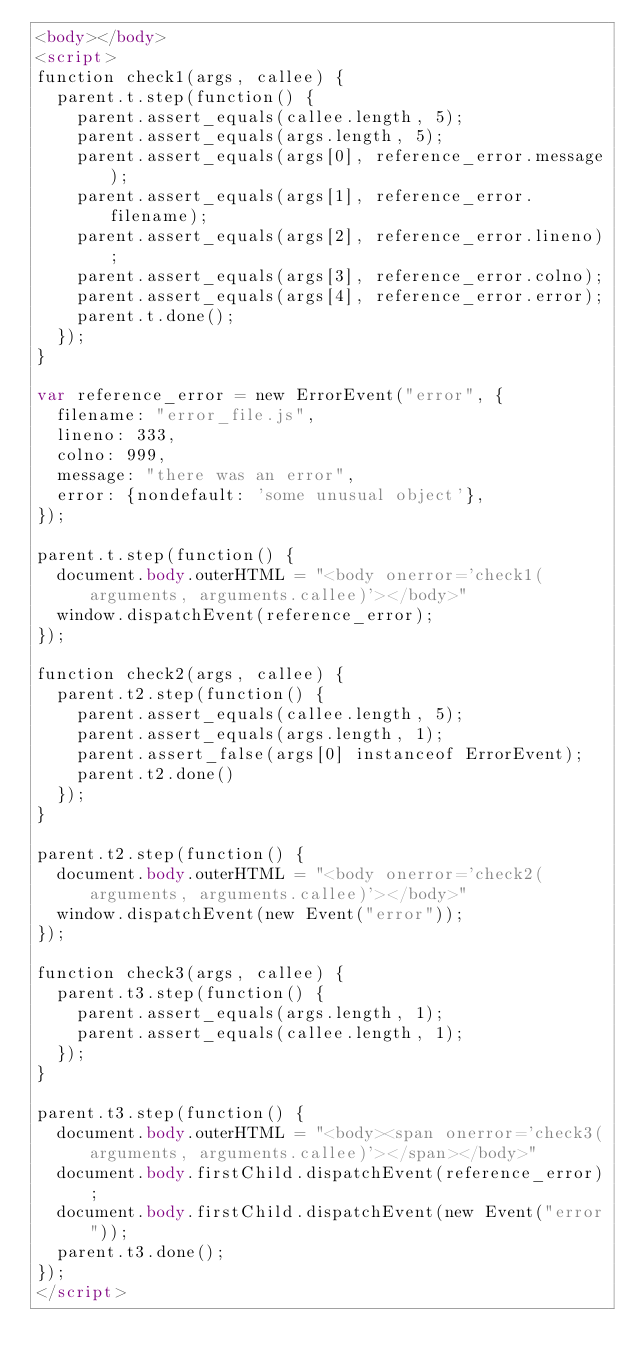<code> <loc_0><loc_0><loc_500><loc_500><_HTML_><body></body>
<script>
function check1(args, callee) {
  parent.t.step(function() {
    parent.assert_equals(callee.length, 5);
    parent.assert_equals(args.length, 5);
    parent.assert_equals(args[0], reference_error.message);
    parent.assert_equals(args[1], reference_error.filename);
    parent.assert_equals(args[2], reference_error.lineno);
    parent.assert_equals(args[3], reference_error.colno);
    parent.assert_equals(args[4], reference_error.error);
    parent.t.done();
  });
}

var reference_error = new ErrorEvent("error", {
  filename: "error_file.js",
  lineno: 333,
  colno: 999,
  message: "there was an error",
  error: {nondefault: 'some unusual object'},
});

parent.t.step(function() {
  document.body.outerHTML = "<body onerror='check1(arguments, arguments.callee)'></body>"
  window.dispatchEvent(reference_error);
});

function check2(args, callee) {
  parent.t2.step(function() {
    parent.assert_equals(callee.length, 5);
    parent.assert_equals(args.length, 1);
    parent.assert_false(args[0] instanceof ErrorEvent);
    parent.t2.done()
  });
}

parent.t2.step(function() {
  document.body.outerHTML = "<body onerror='check2(arguments, arguments.callee)'></body>"
  window.dispatchEvent(new Event("error"));
});

function check3(args, callee) {
  parent.t3.step(function() {
    parent.assert_equals(args.length, 1);
    parent.assert_equals(callee.length, 1);
  });
}

parent.t3.step(function() {
  document.body.outerHTML = "<body><span onerror='check3(arguments, arguments.callee)'></span></body>"
  document.body.firstChild.dispatchEvent(reference_error);
  document.body.firstChild.dispatchEvent(new Event("error"));
  parent.t3.done();
});
</script>
</code> 